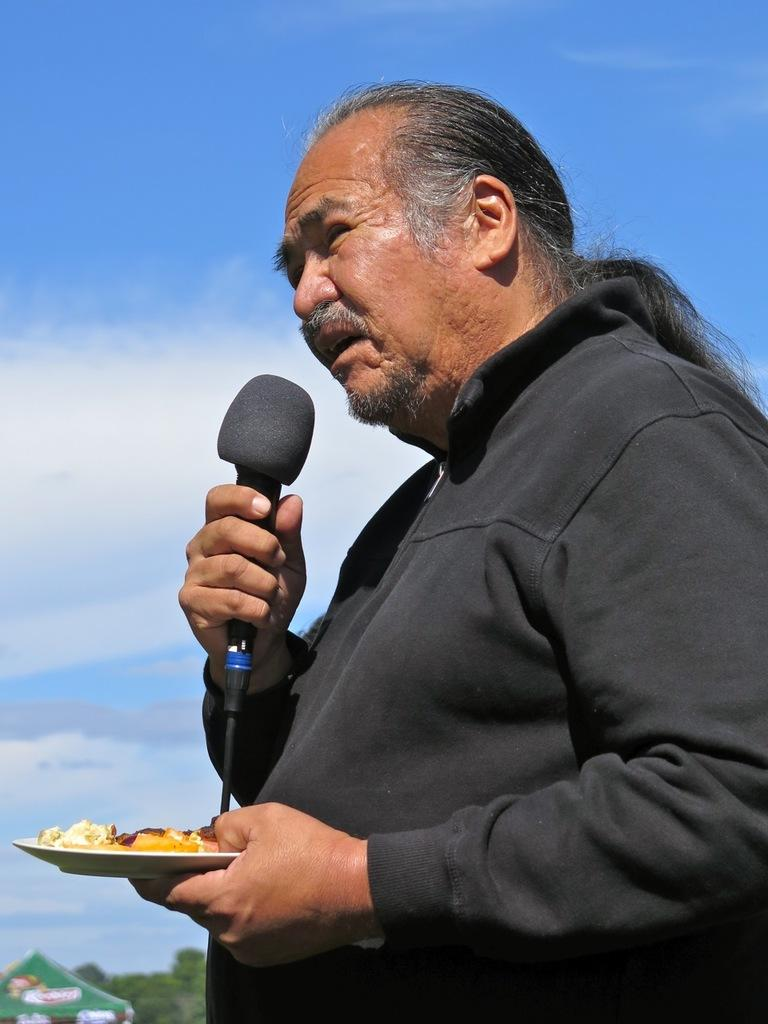What is the man in the image holding in his right hand? The man is holding a microphone in his right hand. What is the man holding in his left hand? The man is holding a bowl with food in his left hand. What can be seen in the background of the image? The sky is visible in the image, and it is blue in color. What type of leather is the man wearing in the image? There is no leather visible in the image; the man is not wearing any clothing that would be made of leather. 